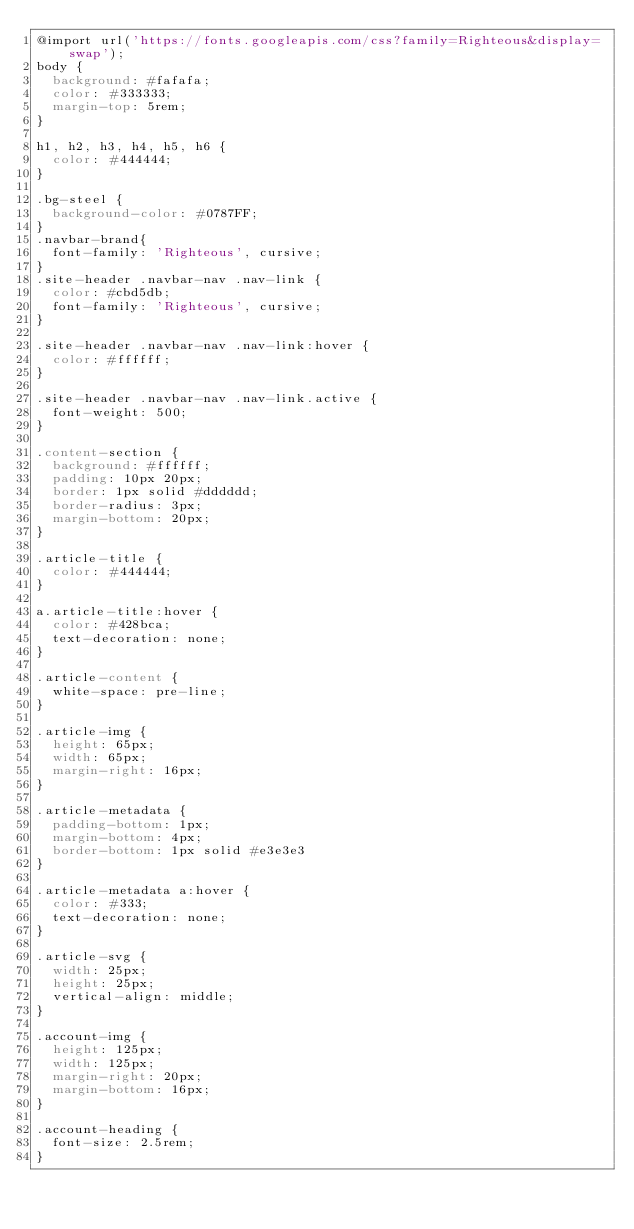<code> <loc_0><loc_0><loc_500><loc_500><_CSS_>@import url('https://fonts.googleapis.com/css?family=Righteous&display=swap');
body {
  background: #fafafa;
  color: #333333;
  margin-top: 5rem;
}

h1, h2, h3, h4, h5, h6 {
  color: #444444;
}

.bg-steel {
  background-color: #0787FF;
}
.navbar-brand{
  font-family: 'Righteous', cursive;
}
.site-header .navbar-nav .nav-link {
  color: #cbd5db;
  font-family: 'Righteous', cursive;
}

.site-header .navbar-nav .nav-link:hover {
  color: #ffffff;
}

.site-header .navbar-nav .nav-link.active {
  font-weight: 500;
}

.content-section {
  background: #ffffff;
  padding: 10px 20px;
  border: 1px solid #dddddd;
  border-radius: 3px;
  margin-bottom: 20px;
}

.article-title {
  color: #444444;
}

a.article-title:hover {
  color: #428bca;
  text-decoration: none;
}

.article-content {
  white-space: pre-line;
}

.article-img {
  height: 65px;
  width: 65px;
  margin-right: 16px;
}

.article-metadata {
  padding-bottom: 1px;
  margin-bottom: 4px;
  border-bottom: 1px solid #e3e3e3
}

.article-metadata a:hover {
  color: #333;
  text-decoration: none;
}

.article-svg {
  width: 25px;
  height: 25px;
  vertical-align: middle;
}

.account-img {
  height: 125px;
  width: 125px;
  margin-right: 20px;
  margin-bottom: 16px;
}

.account-heading {
  font-size: 2.5rem;
}</code> 